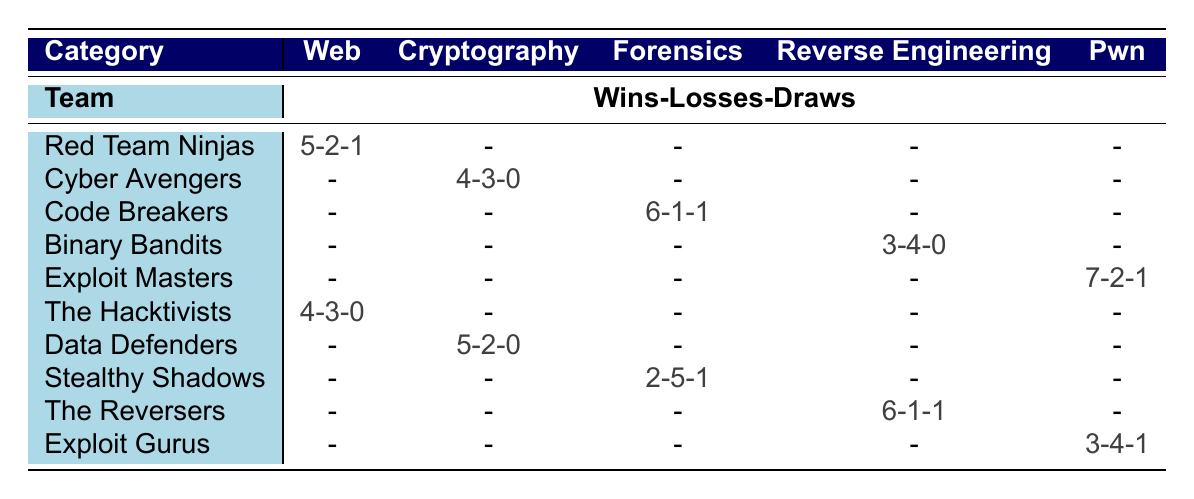What is the total number of wins for the Code Breakers? The table shows that the Code Breakers have won 6 times in the Forensics category. Therefore, the total number of wins for this team is simply the value listed in that cell.
Answer: 6 Which team had the highest number of draws? By examining the table, the maximum number of draws is 1. The teams that had 1 draw are Red Team Ninjas, Code Breakers, Stealthy Shadows, The Reversers, and Exploit Gurus, so none of them stands out in terms of draws alone.
Answer: Multiple teams had the same highest draws How many total losses did the Data Defenders incur? According to the table, the Data Defenders had 2 losses in Cryptography. This is the only value for losses for that team, so the total is directly taken from the cell.
Answer: 2 What is the average number of wins across all teams in the Web category? In the Web category, the teams are Red Team Ninjas and The Hacktivists. Their wins are 5 and 4, respectively. The sum of wins is 5 + 4 = 9. There are 2 teams, so the average is 9/2 = 4.5.
Answer: 4.5 Is it true that all teams in the Cryptography category have more wins than losses? Analyzing the Cryptography category, Cyber Avengers won 4 and lost 3 while Data Defenders won 5 and lost 2. Both teams have more wins than losses, thus the statement holds true.
Answer: Yes What is the combined total for losses from the Reverse Engineering category? The teams in Reverse Engineering are Binary Bandits with 4 losses and The Reversers with 1 loss. Adding these together gives 4 + 1 = 5 losses in total for this category.
Answer: 5 Which team had the least number of wins? Looking through the table, Stealthy Shadows has the lowest number of wins, totaling 2 in the Forensics category. There are no other teams with fewer wins.
Answer: Stealthy Shadows What is the total number of outcomes (wins + losses + draws) for Exploit Masters? For Exploit Masters, they have 7 wins, 2 losses, and 1 draw. Adding these together provides the total outcomes: 7 + 2 + 1 = 10.
Answer: 10 